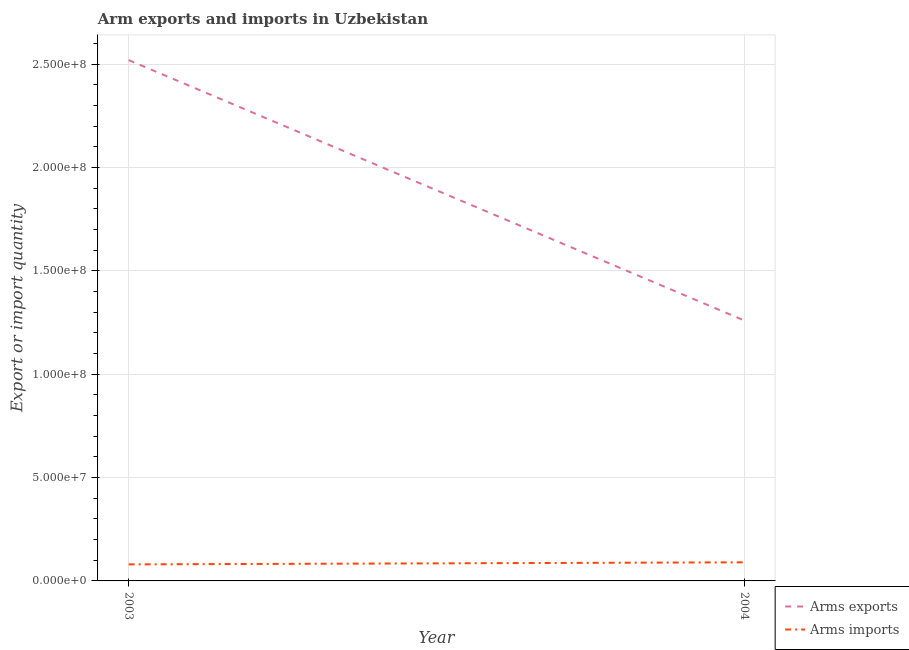How many different coloured lines are there?
Give a very brief answer. 2. What is the arms imports in 2004?
Offer a terse response. 9.00e+06. Across all years, what is the maximum arms exports?
Make the answer very short. 2.52e+08. Across all years, what is the minimum arms imports?
Make the answer very short. 8.00e+06. In which year was the arms imports minimum?
Give a very brief answer. 2003. What is the total arms exports in the graph?
Ensure brevity in your answer.  3.78e+08. What is the difference between the arms imports in 2003 and that in 2004?
Offer a terse response. -1.00e+06. What is the difference between the arms exports in 2003 and the arms imports in 2004?
Offer a terse response. 2.43e+08. What is the average arms exports per year?
Keep it short and to the point. 1.89e+08. In the year 2003, what is the difference between the arms exports and arms imports?
Ensure brevity in your answer.  2.44e+08. Is the arms imports in 2003 less than that in 2004?
Offer a terse response. Yes. Is the arms imports strictly greater than the arms exports over the years?
Provide a short and direct response. No. How many years are there in the graph?
Your response must be concise. 2. What is the difference between two consecutive major ticks on the Y-axis?
Your response must be concise. 5.00e+07. Are the values on the major ticks of Y-axis written in scientific E-notation?
Ensure brevity in your answer.  Yes. Does the graph contain any zero values?
Keep it short and to the point. No. How many legend labels are there?
Offer a very short reply. 2. How are the legend labels stacked?
Make the answer very short. Vertical. What is the title of the graph?
Offer a very short reply. Arm exports and imports in Uzbekistan. Does "Under five" appear as one of the legend labels in the graph?
Give a very brief answer. No. What is the label or title of the Y-axis?
Make the answer very short. Export or import quantity. What is the Export or import quantity in Arms exports in 2003?
Make the answer very short. 2.52e+08. What is the Export or import quantity of Arms exports in 2004?
Keep it short and to the point. 1.26e+08. What is the Export or import quantity of Arms imports in 2004?
Provide a short and direct response. 9.00e+06. Across all years, what is the maximum Export or import quantity of Arms exports?
Your answer should be compact. 2.52e+08. Across all years, what is the maximum Export or import quantity of Arms imports?
Ensure brevity in your answer.  9.00e+06. Across all years, what is the minimum Export or import quantity of Arms exports?
Your answer should be compact. 1.26e+08. What is the total Export or import quantity of Arms exports in the graph?
Provide a short and direct response. 3.78e+08. What is the total Export or import quantity of Arms imports in the graph?
Provide a short and direct response. 1.70e+07. What is the difference between the Export or import quantity in Arms exports in 2003 and that in 2004?
Your answer should be compact. 1.26e+08. What is the difference between the Export or import quantity of Arms imports in 2003 and that in 2004?
Provide a succinct answer. -1.00e+06. What is the difference between the Export or import quantity in Arms exports in 2003 and the Export or import quantity in Arms imports in 2004?
Make the answer very short. 2.43e+08. What is the average Export or import quantity of Arms exports per year?
Keep it short and to the point. 1.89e+08. What is the average Export or import quantity of Arms imports per year?
Offer a terse response. 8.50e+06. In the year 2003, what is the difference between the Export or import quantity in Arms exports and Export or import quantity in Arms imports?
Provide a succinct answer. 2.44e+08. In the year 2004, what is the difference between the Export or import quantity of Arms exports and Export or import quantity of Arms imports?
Offer a very short reply. 1.17e+08. What is the ratio of the Export or import quantity in Arms exports in 2003 to that in 2004?
Give a very brief answer. 2. What is the ratio of the Export or import quantity of Arms imports in 2003 to that in 2004?
Your answer should be compact. 0.89. What is the difference between the highest and the second highest Export or import quantity of Arms exports?
Give a very brief answer. 1.26e+08. What is the difference between the highest and the second highest Export or import quantity in Arms imports?
Keep it short and to the point. 1.00e+06. What is the difference between the highest and the lowest Export or import quantity of Arms exports?
Provide a short and direct response. 1.26e+08. What is the difference between the highest and the lowest Export or import quantity of Arms imports?
Your response must be concise. 1.00e+06. 